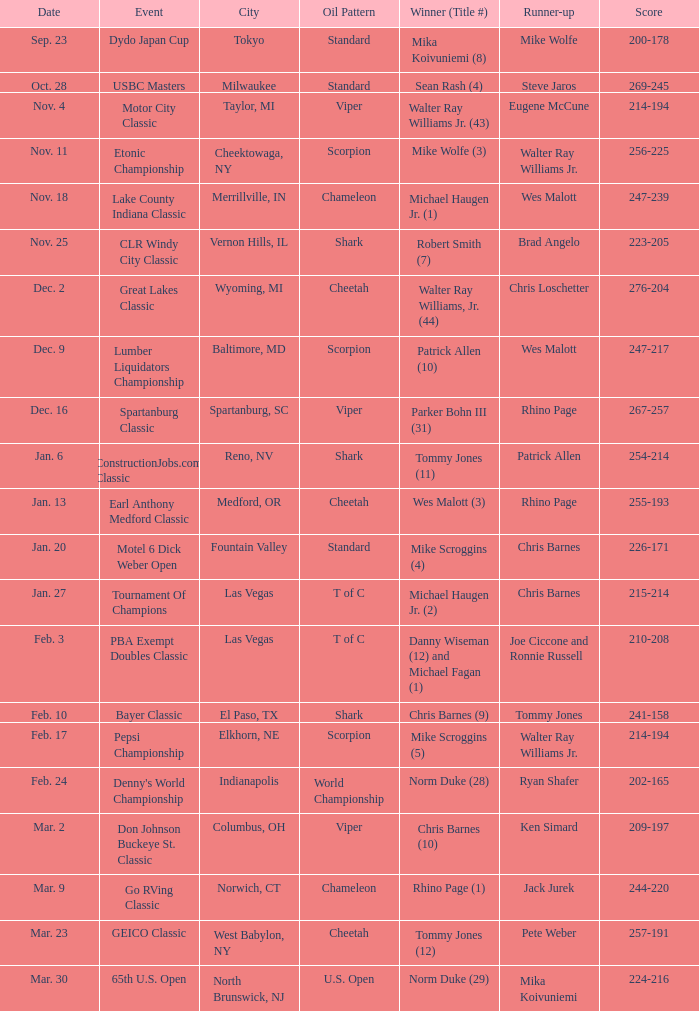Name the Date when has  robert smith (7)? Nov. 25. 